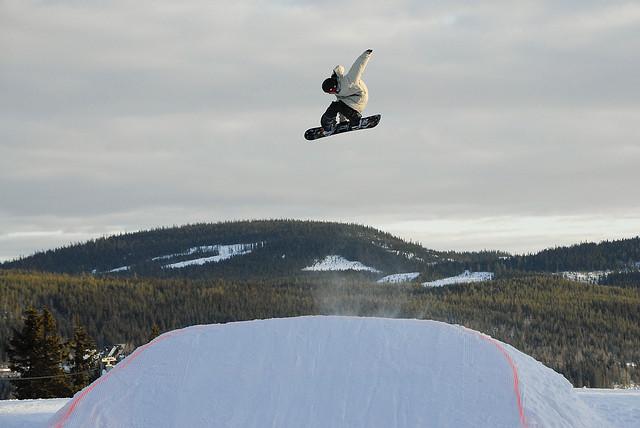Is the boy flying?
Write a very short answer. No. What is the color of the snow?
Be succinct. White. What color is the coat?
Concise answer only. White. 